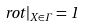<formula> <loc_0><loc_0><loc_500><loc_500>\ r o t | _ { X \in \Gamma } = 1</formula> 